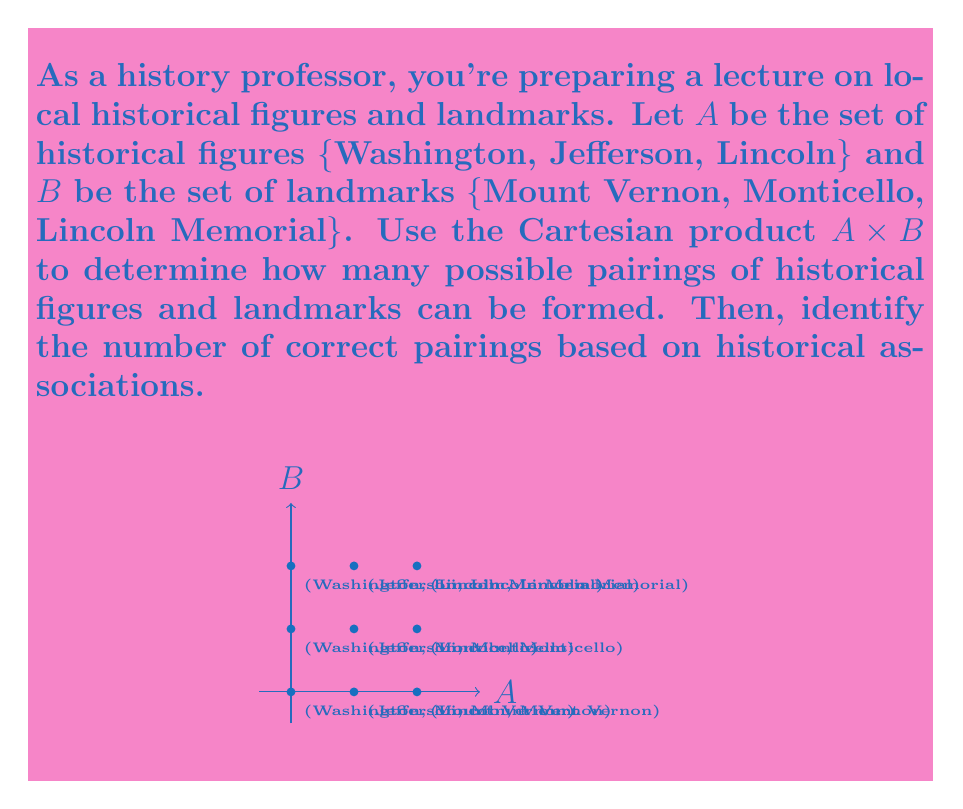Can you solve this math problem? Let's approach this step-by-step:

1) First, we need to understand what the Cartesian product is:
   The Cartesian product A × B is the set of all ordered pairs (a, b) where a ∈ A and b ∈ B.

2) To find the number of elements in A × B, we use the multiplication principle:
   $|A \times B| = |A| \cdot |B|$

3) In this case:
   $|A| = 3$ (Washington, Jefferson, Lincoln)
   $|B| = 3$ (Mount Vernon, Monticello, Lincoln Memorial)

4) Therefore:
   $|A \times B| = 3 \cdot 3 = 9$

5) This means there are 9 possible pairings in total.

6) Now, for the correct historical associations:
   - Washington is associated with Mount Vernon
   - Jefferson is associated with Monticello
   - Lincoln is associated with the Lincoln Memorial

7) Counting these correct associations, we find there are 3 correct pairings.

8) The ratio of correct pairings to total possible pairings is:
   $\frac{3}{9} = \frac{1}{3}$
Answer: 9 total pairings, 3 correct pairings 